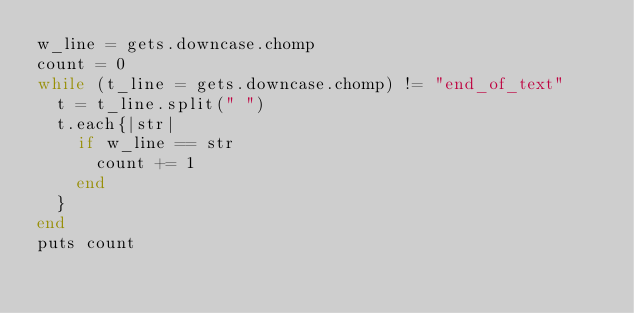Convert code to text. <code><loc_0><loc_0><loc_500><loc_500><_Ruby_>w_line = gets.downcase.chomp
count = 0
while (t_line = gets.downcase.chomp) != "end_of_text" 
  t = t_line.split(" ")
  t.each{|str|
    if w_line == str
      count += 1
    end
  }
end
puts count




</code> 